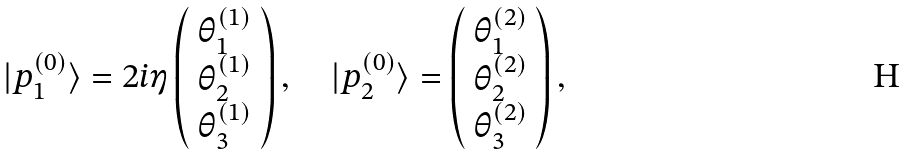Convert formula to latex. <formula><loc_0><loc_0><loc_500><loc_500>| p ^ { ( 0 ) } _ { 1 } \rangle = 2 i \eta \left ( \begin{array} { c } \theta ^ { ( 1 ) } _ { 1 } \\ \theta ^ { ( 1 ) } _ { 2 } \\ \theta ^ { ( 1 ) } _ { 3 } \end{array} \right ) , \quad | p ^ { ( 0 ) } _ { 2 } \rangle = \left ( \begin{array} { c } \theta ^ { ( 2 ) } _ { 1 } \\ \theta ^ { ( 2 ) } _ { 2 } \\ \theta ^ { ( 2 ) } _ { 3 } \end{array} \right ) ,</formula> 